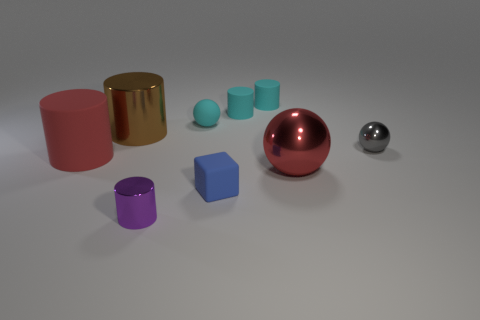Subtract all blue cylinders. Subtract all green blocks. How many cylinders are left? 5 Add 1 gray objects. How many objects exist? 10 Subtract all spheres. How many objects are left? 6 Add 1 small purple metal objects. How many small purple metal objects are left? 2 Add 2 tiny cyan things. How many tiny cyan things exist? 5 Subtract 0 brown blocks. How many objects are left? 9 Subtract all large red rubber cylinders. Subtract all blue things. How many objects are left? 7 